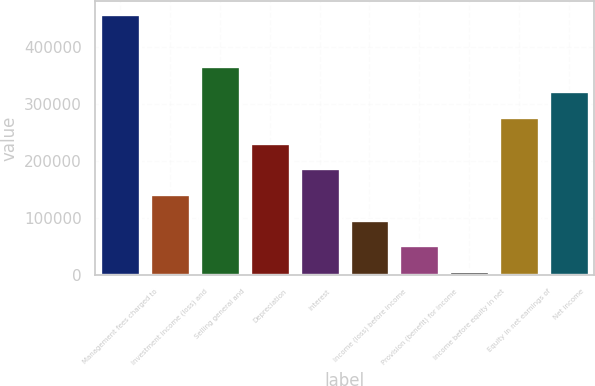Convert chart. <chart><loc_0><loc_0><loc_500><loc_500><bar_chart><fcel>Management fees charged to<fcel>Investment income (loss) and<fcel>Selling general and<fcel>Depreciation<fcel>Interest<fcel>Income (loss) before income<fcel>Provision (benefit) for income<fcel>Income before equity in net<fcel>Equity in net earnings of<fcel>Net income<nl><fcel>458373<fcel>142107<fcel>368011<fcel>232468<fcel>187288<fcel>96925.8<fcel>51744.9<fcel>6564<fcel>277649<fcel>322830<nl></chart> 